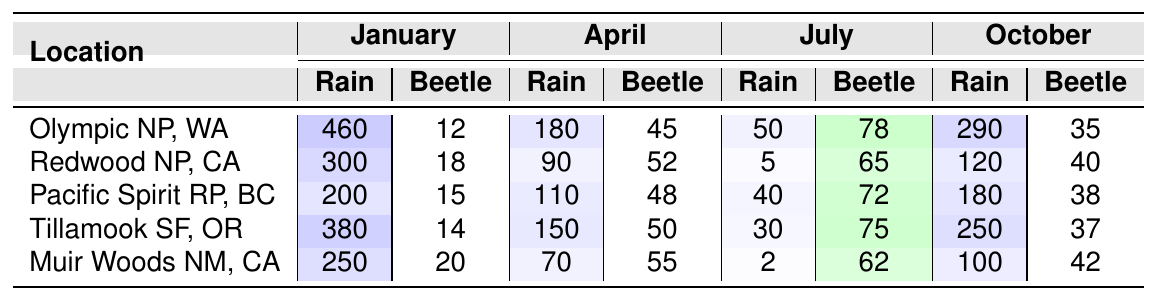What is the total rainfall recorded in July for all locations? To find the total rainfall for July, we need to sum the rainfall for each location listed in July: 50 (Olympic NP) + 5 (Redwood NP) + 40 (Pacific Spirit RP) + 30 (Tillamook SF) + 2 (Muir Woods NM) = 127 mm
Answer: 127 mm Which location had the highest beetle activity in April? In April, the beetle activity by location is as follows: 45 (Olympic NP), 52 (Redwood NP), 48 (Pacific Spirit RP), 50 (Tillamook SF), and 55 (Muir Woods NM). The highest value is from Muir Woods National Monument.
Answer: Muir Woods National Monument What is the average beetle activity across all locations in October? To calculate the average beetle activity in October, we sum the beetle activities: 35 (Olympic NP) + 40 (Redwood NP) + 38 (Pacific Spirit RP) + 37 (Tillamook SF) + 42 (Muir Woods NM) = 192, then we divide by the number of locations (5). So, the average is 192 / 5 = 38.4.
Answer: 38.4 Is there a location where beetle activity in July exceeds 70? Checking July beetle activity: Olympic NP (78), Redwood NP (65), Pacific Spirit RP (72), Tillamook SF (75), Muir Woods NM (62). The locations Olympic NP, Pacific Spirit RP, and Tillamook SF have beetle activity exceeding 70.
Answer: Yes In which month does Redwood National Park have the least rainfall, and what is the amount? Looking at Redwood NP, the rainfall amounts for each month are: January (300 mm), April (90 mm), July (5 mm), October (120 mm). The least rainfall occurs in July, with 5 mm.
Answer: July, 5 mm What is the difference in beetle activity between October and April for Tillamook State Forest? The beetle activity for Tillamook State Forest is 50 in April and 37 in October. The difference is 50 - 37 = 13.
Answer: 13 Which location has the most consistent beetle activity across the months? To determine consistency, compare the ranges of beetle activity across the months for each location. Utilizing ranges: Olympic NP (12 to 78), Redwood NP (18 to 65), Pacific Spirit RP (15 to 72), Tillamook SF (14 to 75), Muir Woods NM (20 to 62). The smallest range is Olympic NP, with a range of 66.
Answer: Olympic National Park, WA What is the total beetle activity for Muir Woods National Monument throughout the year? Summing the beetle activity in each month: January (20) + April (55) + July (62) + October (42) gives a total of 179.
Answer: 179 How does the total rainfall in January compare to July for Pacific Spirit Regional Park? The January rainfall for Pacific Spirit is 200 mm and July is 40 mm. The difference is 200 - 40 = 160 mm more in January.
Answer: January is 160 mm more Are there any locations where the beetle activity in January is higher than 15? Checking January beetle activity: Olympic NP (12), Redwood NP (18), Pacific Spirit RP (15), Tillamook SF (14), Muir Woods NM (20). Redwood NP and Muir Woods have activity higher than 15.
Answer: Yes 